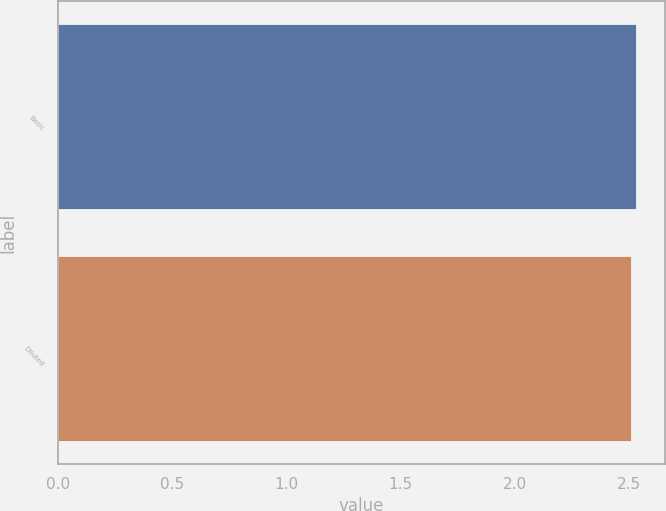Convert chart to OTSL. <chart><loc_0><loc_0><loc_500><loc_500><bar_chart><fcel>Basic<fcel>Diluted<nl><fcel>2.53<fcel>2.51<nl></chart> 